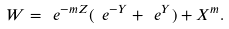<formula> <loc_0><loc_0><loc_500><loc_500>W = \ e ^ { - m Z } ( \ e ^ { - Y } + \ e ^ { Y } ) + X ^ { m } .</formula> 